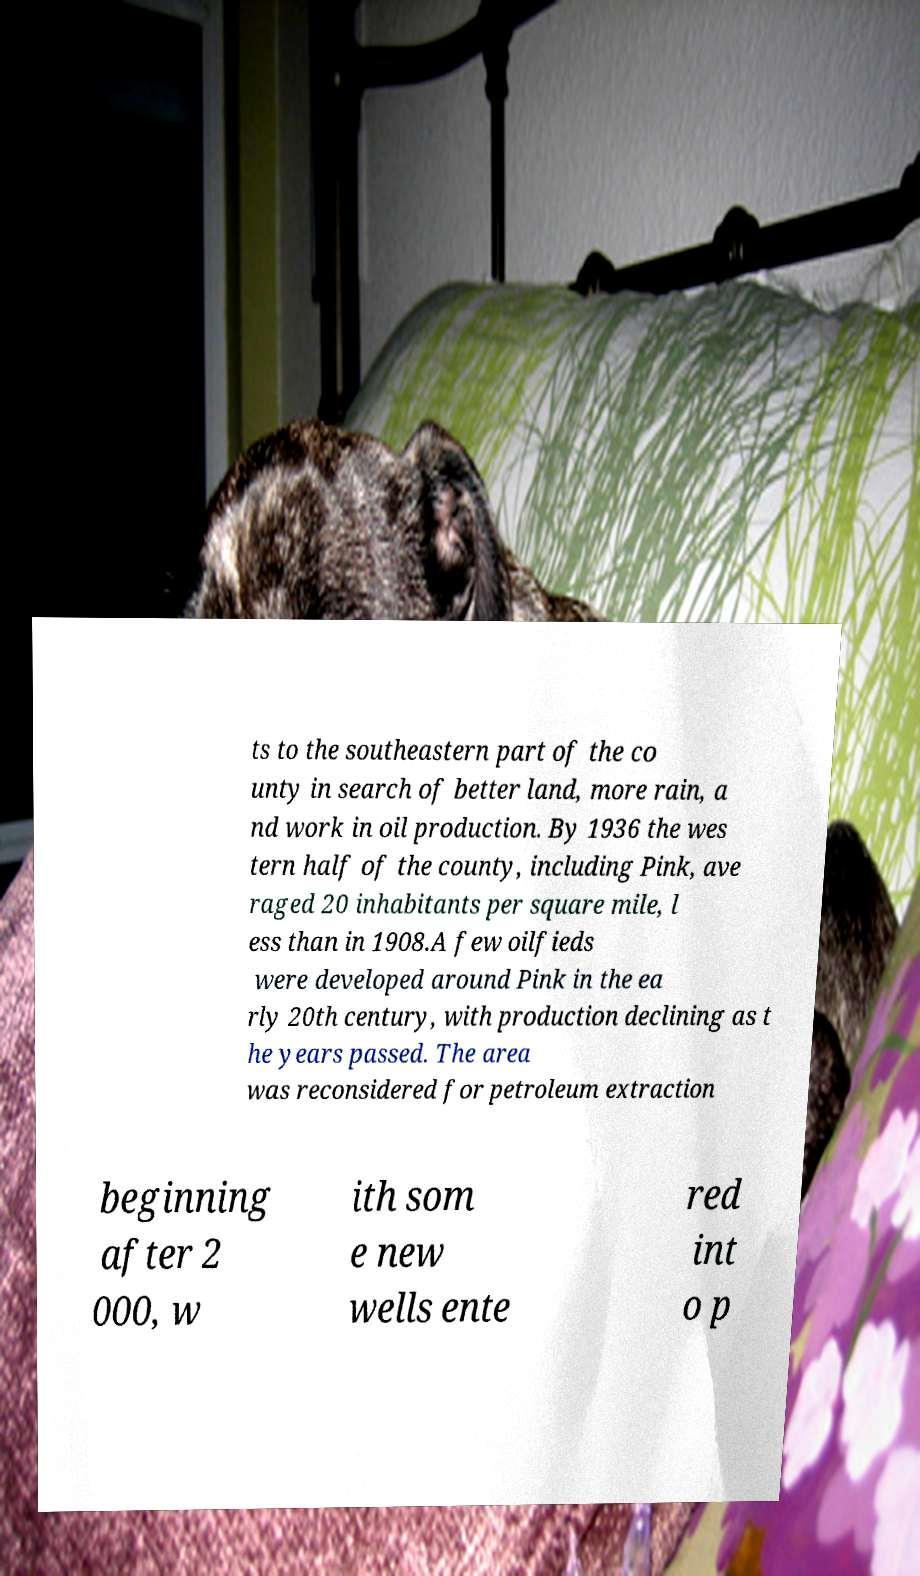Please read and relay the text visible in this image. What does it say? ts to the southeastern part of the co unty in search of better land, more rain, a nd work in oil production. By 1936 the wes tern half of the county, including Pink, ave raged 20 inhabitants per square mile, l ess than in 1908.A few oilfieds were developed around Pink in the ea rly 20th century, with production declining as t he years passed. The area was reconsidered for petroleum extraction beginning after 2 000, w ith som e new wells ente red int o p 